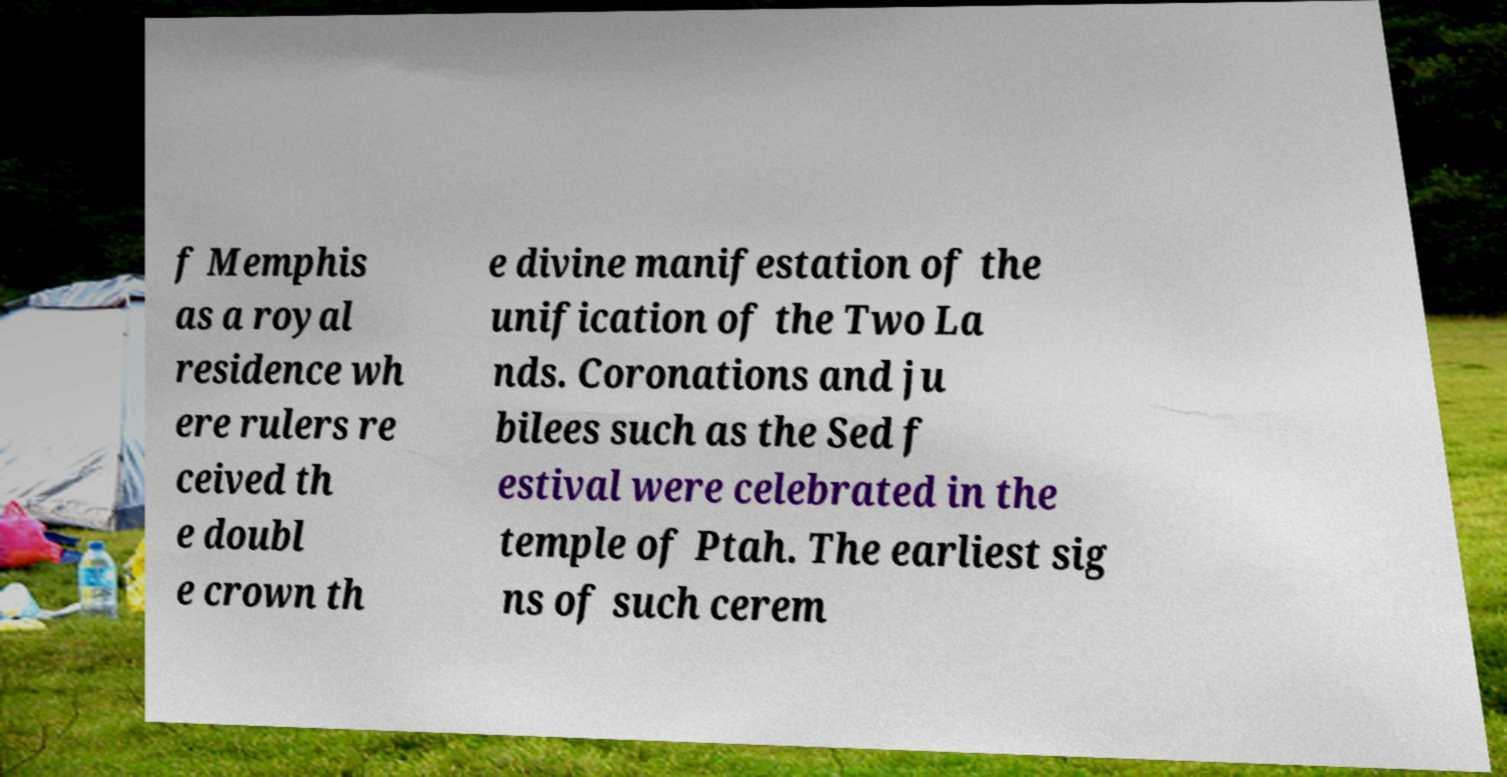Can you read and provide the text displayed in the image?This photo seems to have some interesting text. Can you extract and type it out for me? f Memphis as a royal residence wh ere rulers re ceived th e doubl e crown th e divine manifestation of the unification of the Two La nds. Coronations and ju bilees such as the Sed f estival were celebrated in the temple of Ptah. The earliest sig ns of such cerem 